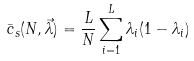<formula> <loc_0><loc_0><loc_500><loc_500>\bar { c } _ { s } ( N , \vec { \lambda } ) = \frac { L } { N } \sum _ { i = 1 } ^ { L } \lambda _ { i } ( 1 - \lambda _ { i } )</formula> 